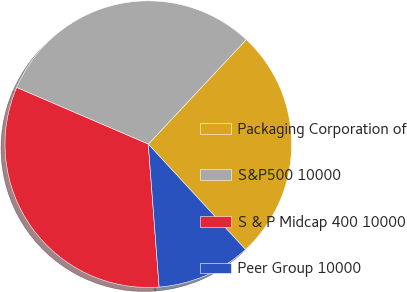<chart> <loc_0><loc_0><loc_500><loc_500><pie_chart><fcel>Packaging Corporation of<fcel>S&P500 10000<fcel>S & P Midcap 400 10000<fcel>Peer Group 10000<nl><fcel>26.16%<fcel>30.51%<fcel>32.67%<fcel>10.66%<nl></chart> 